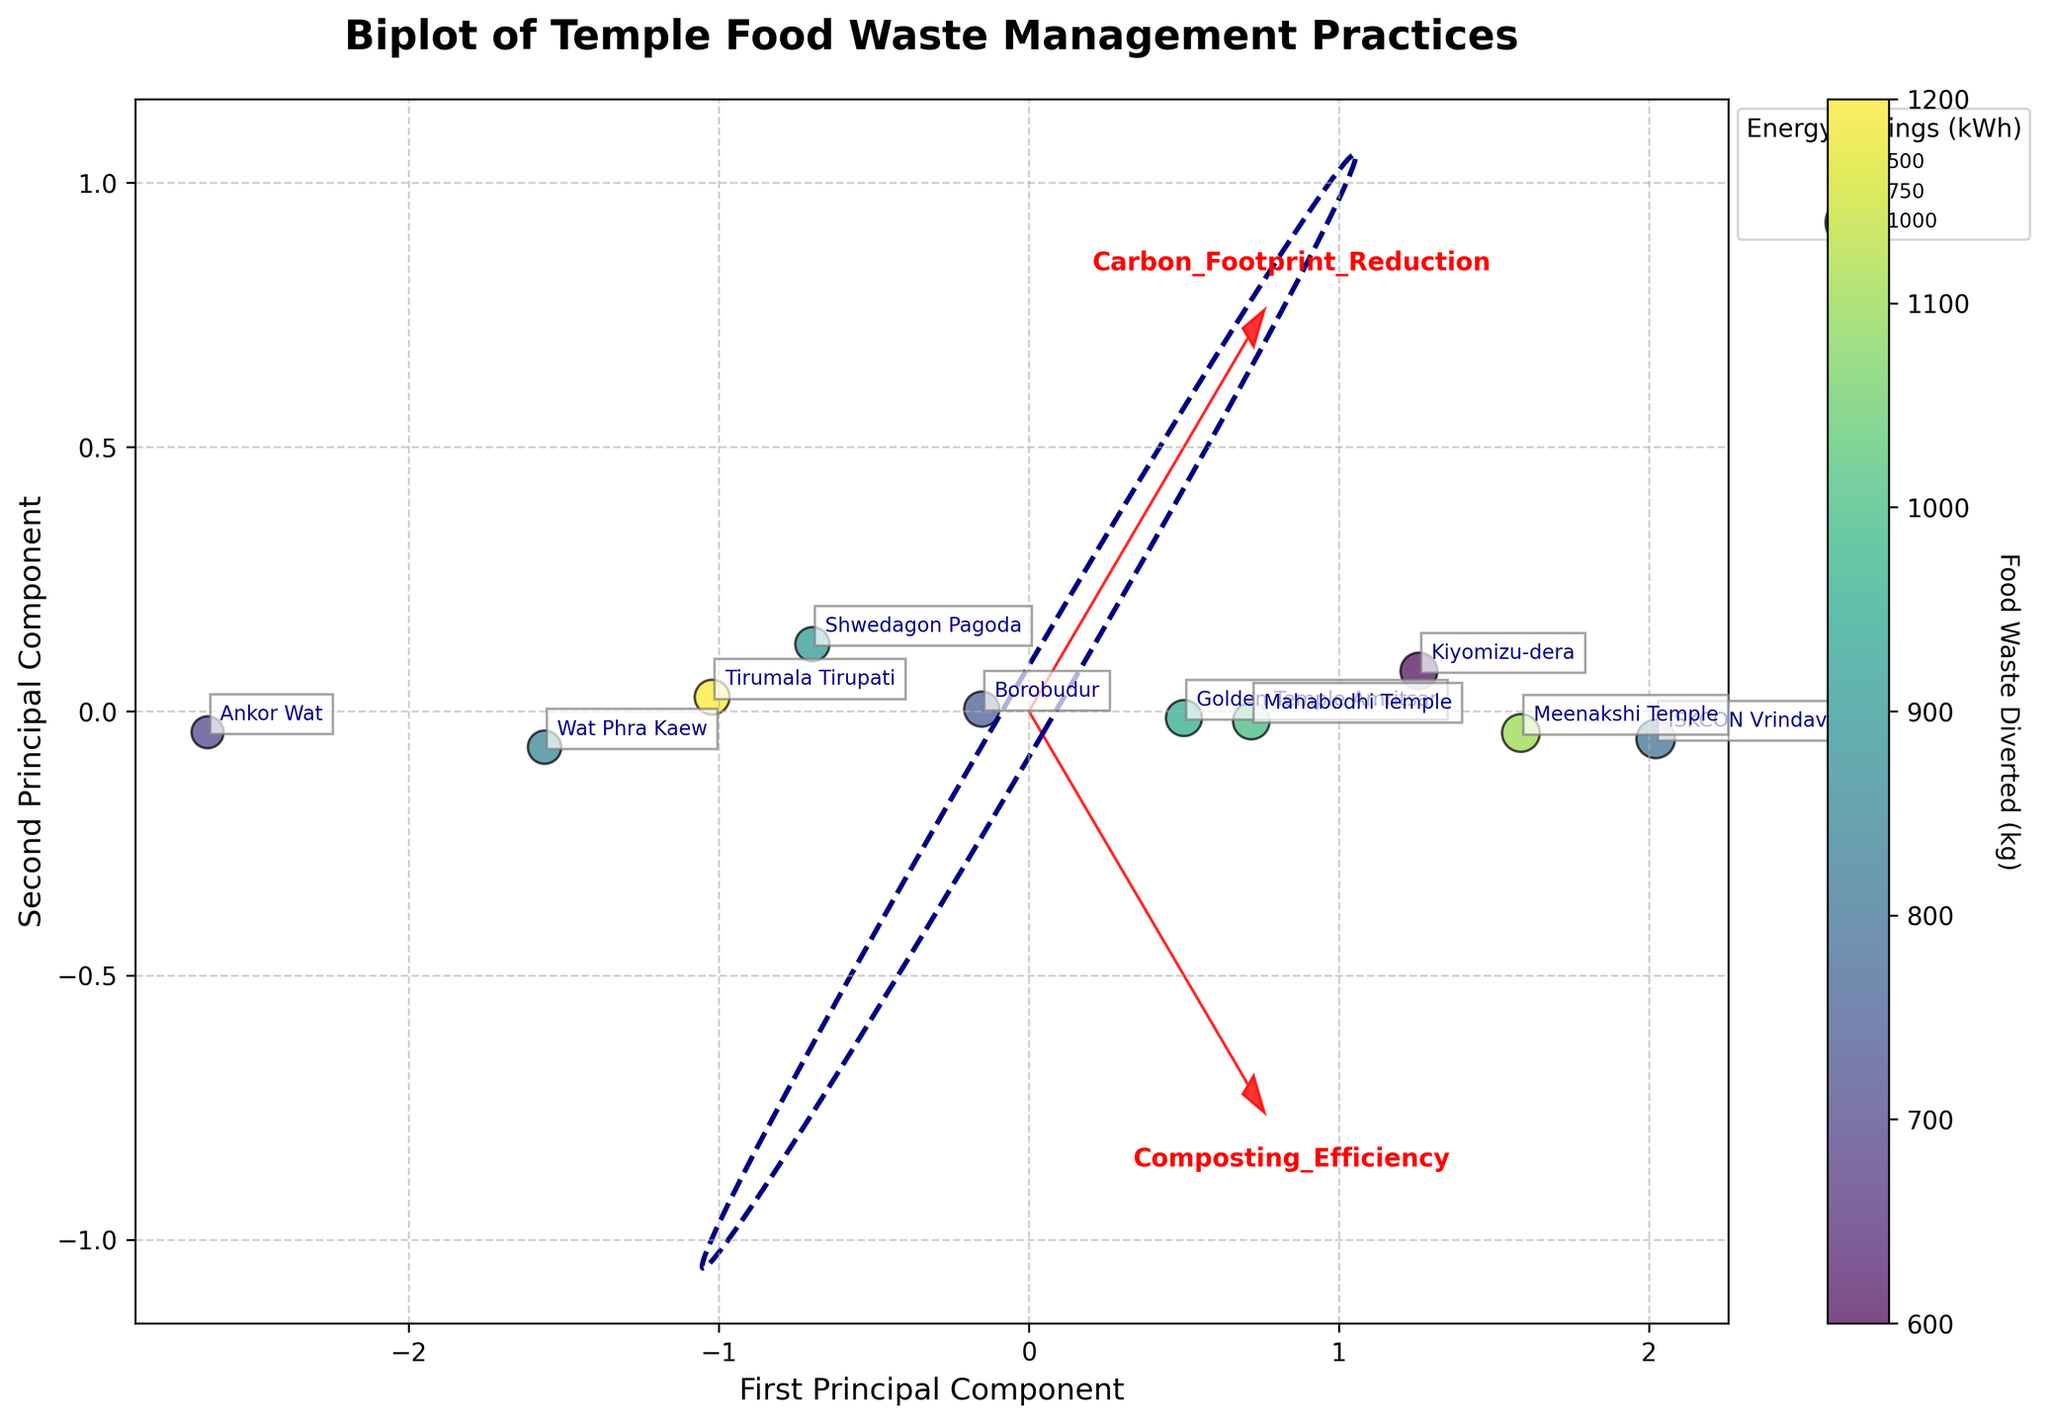What's the title of the biplot? The title of the biplot is displayed at the top of the figure. It reads "Biplot of Temple Food Waste Management Practices".
Answer: Biplot of Temple Food Waste Management Practices Which temple has the highest Composting Efficiency? The temple with the highest Composting Efficiency can be identified by locating the longest vector in the direction of the "Composting_Efficiency" arrow. This is ISKCON Vrindavan.
Answer: ISKCON Vrindavan What does the color of the scatter points represent? The color of each scatter point corresponds to the amount of Food Waste Diverted, as indicated by the color bar on the right side of the plot labeled “Food Waste Diverted (kg)”.
Answer: Food Waste Diverted (kg) Which principal component has the highest eigenvalue and why? The higher variance explained by each component is represented by the size of the ellipse along each axis. The first principal component shows a larger semi-axis along the x-axis, indicating it captures more variance of the original data.
Answer: First Principal Component Compare the energy savings between the temples with the highest and lowest Carbon Footprint Reduction. The temple with the highest Carbon Footprint Reduction is ISKCON Vrindavan, and the lowest is Ankor Wat. By comparing the sizes of their scatter points, we see ISKCON Vrindavan has larger bubbles representing higher energy savings (710 kWh vs 490 kWh).
Answer: ISKCON Vrindavan - 710 kWh, Ankor Wat - 490 kWh What relationship between Composting Efficiency and Carbon Footprint Reduction can you infer from the biplot? The arrows for Composting Efficiency and Carbon Footprint Reduction are in similar directions, suggesting a positive correlation. Temples with higher Composting Efficiency likely also have higher Carbon Footprint Reduction.
Answer: Positive Correlation Which temple diverts the least amount of food waste and how is it depicted in the plot? Kiyomizu-dera diverts the least amount of food waste (600 kg), shown by the faintest color on the scatter plot.
Answer: Kiyomizu-dera - 600 kg Among the temples, which one shows both high energy savings and high Carbon Footprint Reduction? From the scatter point sizes and proximity to the Carbon Footprint Reduction arrow, ISKCON Vrindavan demonstrates both high energy savings (710 kWh) and high Carbon Footprint Reduction (82%).
Answer: ISKCON Vrindavan How are the feature vectors represented in the biplot and what do they indicate? Feature vectors are represented by red arrows starting at the origin and extending in the direction of variance for each feature (Composting Efficiency and Carbon Footprint Reduction). Their length and direction indicate the direction and variance they explain in the data.
Answer: Red arrows What additional information does the confidence ellipse provide? The confidence ellipse surrounds the origin and aligns with principal component axes, indicating the spread and variance of the data along these components. A broader x-axis spread confirms higher variance in the first principal component.
Answer: Spread and variance of the data 